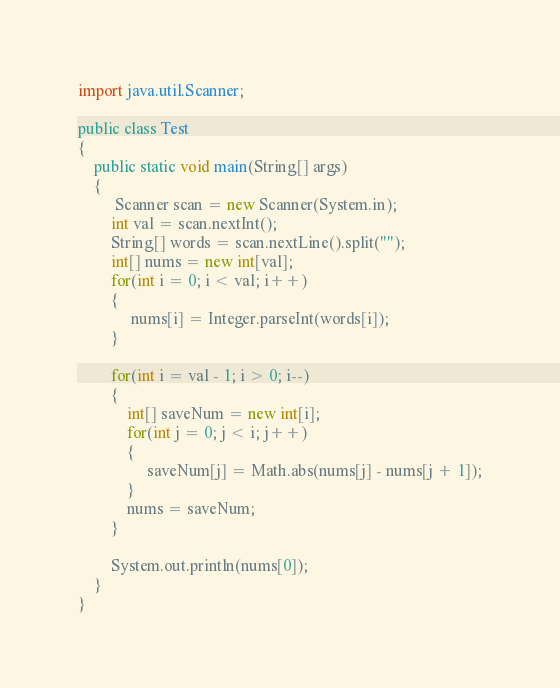<code> <loc_0><loc_0><loc_500><loc_500><_Java_>import java.util.Scanner;
 
public class Test
{
	public static void main(String[] args)
    {
     	 Scanner scan = new Scanner(System.in);
      	int val = scan.nextInt();
      	String[] words = scan.nextLine().split("");
      	int[] nums = new int[val];
      	for(int i = 0; i < val; i++)
        {
         	 nums[i] = Integer.parseInt(words[i]);
        }
      
      	for(int i = val - 1; i > 0; i--)
        {
          	int[] saveNum = new int[i];
         	for(int j = 0; j < i; j++)
            {
             	 saveNum[j] = Math.abs(nums[j] - nums[j + 1]);
            }
          	nums = saveNum;
        }
      
      	System.out.println(nums[0]);
    }
}</code> 